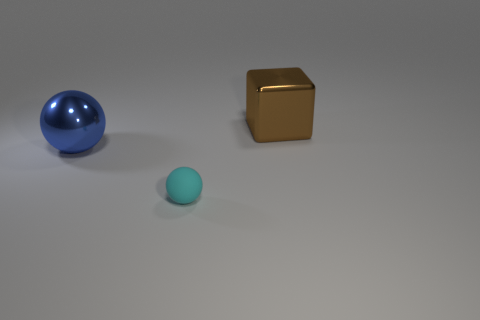What materials do the objects appear to be made of? The larger sphere has a reflective surface that suggests it could be made of a polished metal or plastic. The cube appears to have a matte finish, resembling a metallic or ceramic material, while the small sphere has a texture that implies a soft, matte surface, likely rubber or plastic. 